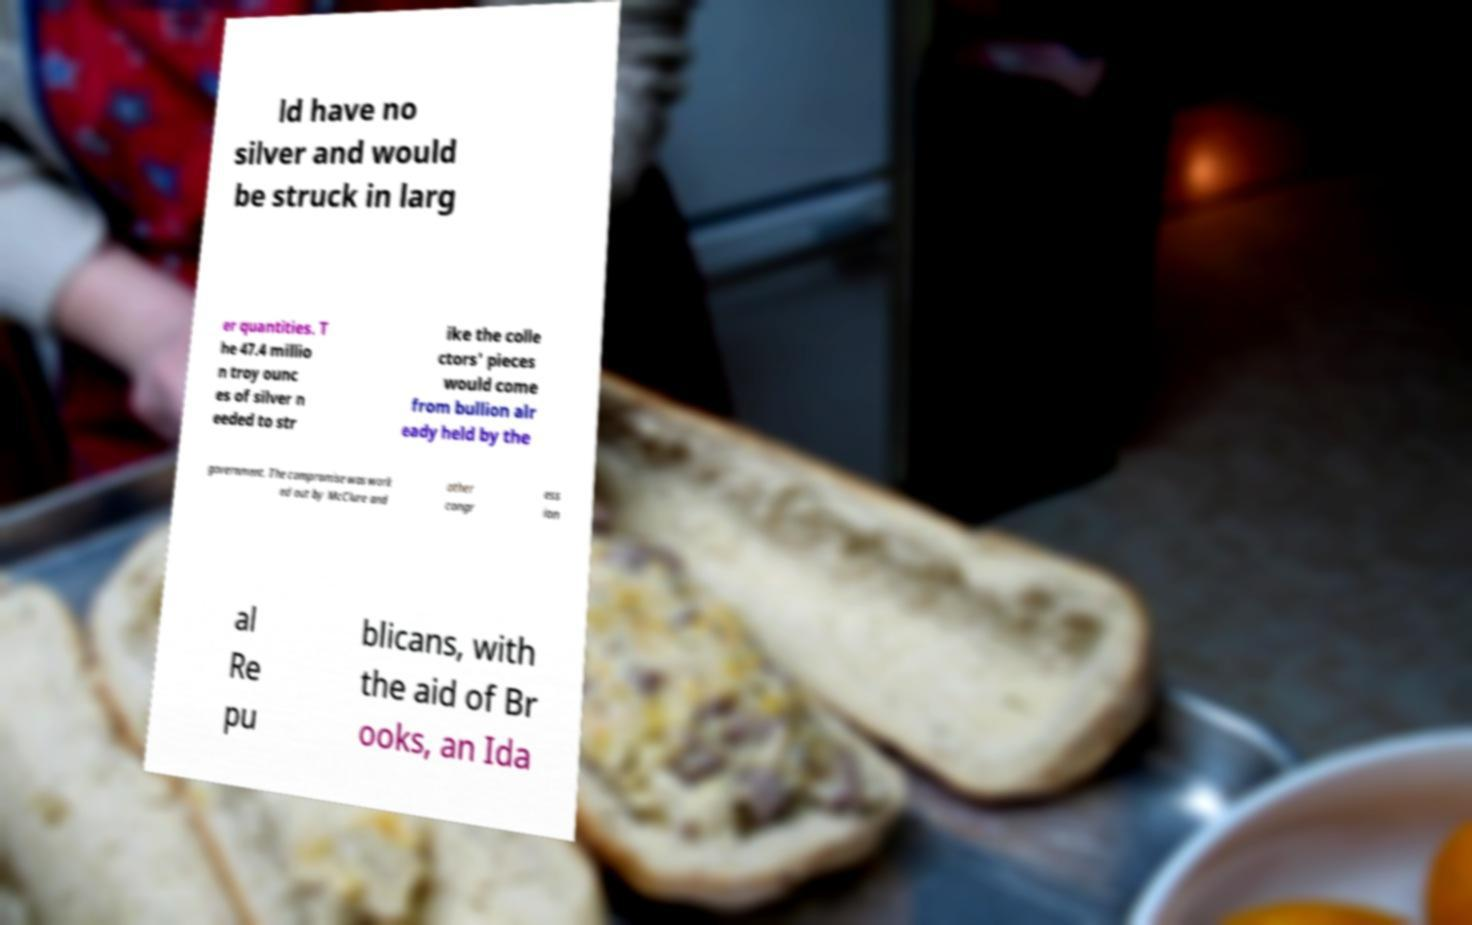Could you extract and type out the text from this image? ld have no silver and would be struck in larg er quantities. T he 47.4 millio n troy ounc es of silver n eeded to str ike the colle ctors' pieces would come from bullion alr eady held by the government. The compromise was work ed out by McClure and other congr ess ion al Re pu blicans, with the aid of Br ooks, an Ida 